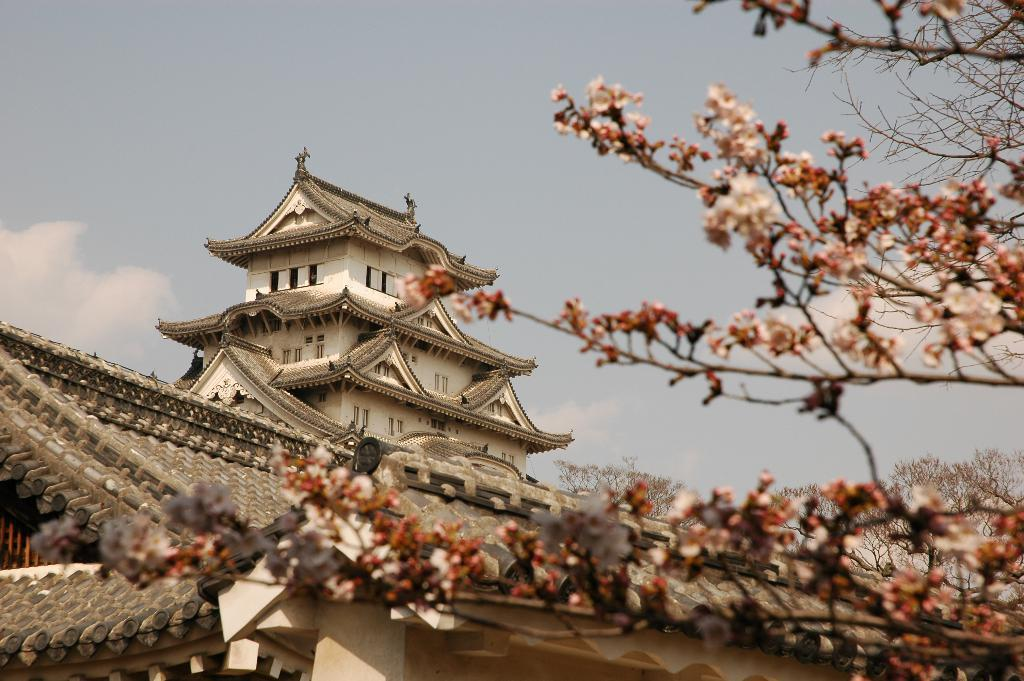What type of tree can be seen in the image? There is a pink flower tree in the image. What other structures or features can be seen in the background of the image? Ancient buildings are present in the background of the image. What is visible in the sky in the image? The sky is visible in the image, and clouds are present in it. How many wrens are perched on the pink flower tree in the image? There are no wrens present in the image; it only features a pink flower tree and ancient buildings in the background. 